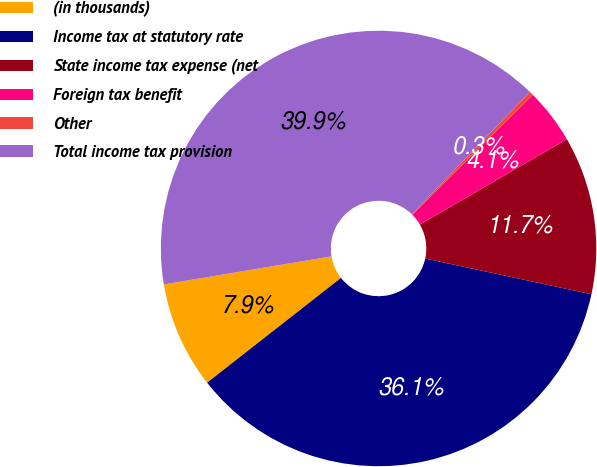<chart> <loc_0><loc_0><loc_500><loc_500><pie_chart><fcel>(in thousands)<fcel>Income tax at statutory rate<fcel>State income tax expense (net<fcel>Foreign tax benefit<fcel>Other<fcel>Total income tax provision<nl><fcel>7.93%<fcel>36.06%<fcel>11.74%<fcel>4.11%<fcel>0.3%<fcel>39.87%<nl></chart> 